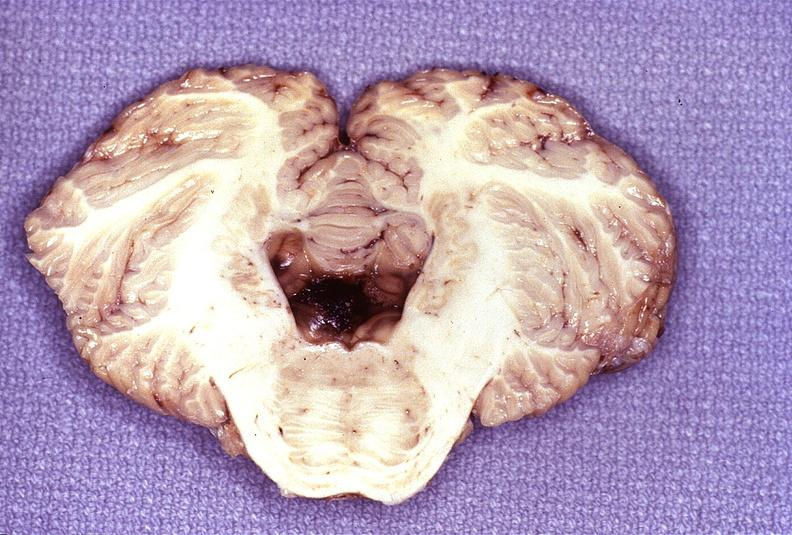s nervous present?
Answer the question using a single word or phrase. Yes 